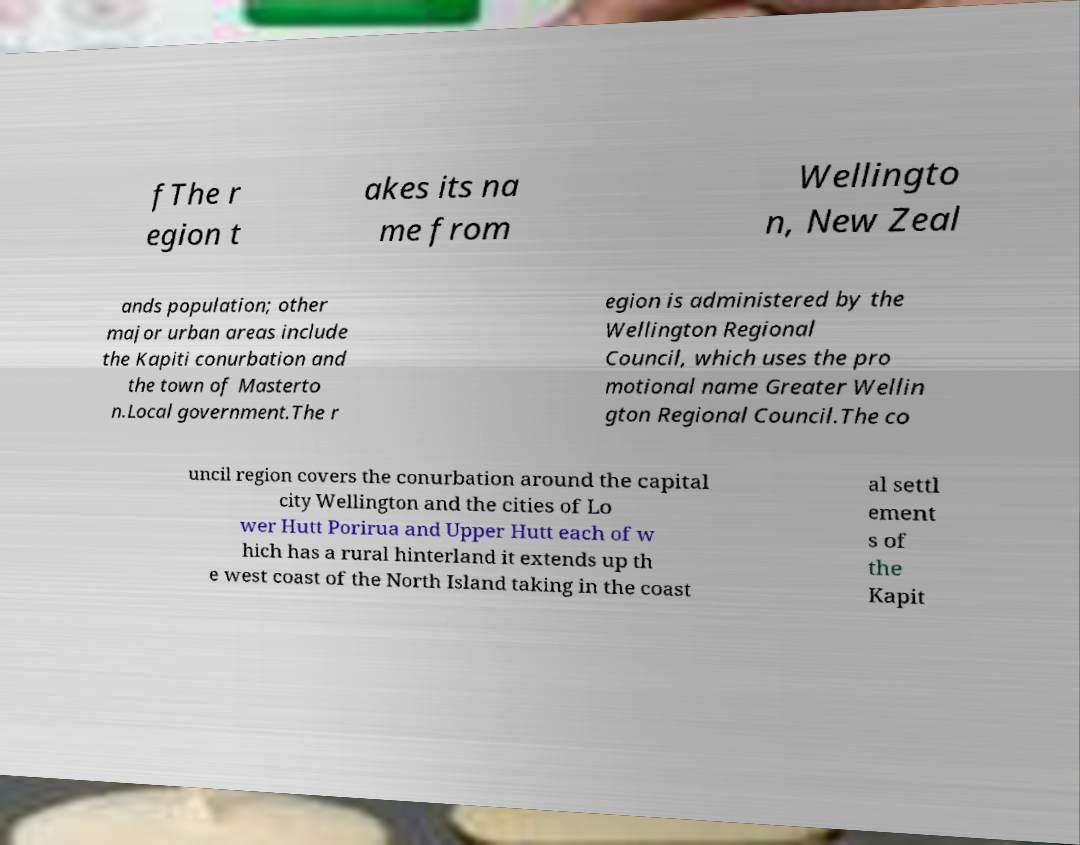For documentation purposes, I need the text within this image transcribed. Could you provide that? fThe r egion t akes its na me from Wellingto n, New Zeal ands population; other major urban areas include the Kapiti conurbation and the town of Masterto n.Local government.The r egion is administered by the Wellington Regional Council, which uses the pro motional name Greater Wellin gton Regional Council.The co uncil region covers the conurbation around the capital city Wellington and the cities of Lo wer Hutt Porirua and Upper Hutt each of w hich has a rural hinterland it extends up th e west coast of the North Island taking in the coast al settl ement s of the Kapit 